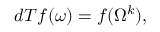Convert formula to latex. <formula><loc_0><loc_0><loc_500><loc_500>d T f ( \omega ) = f ( \Omega ^ { k } ) ,</formula> 